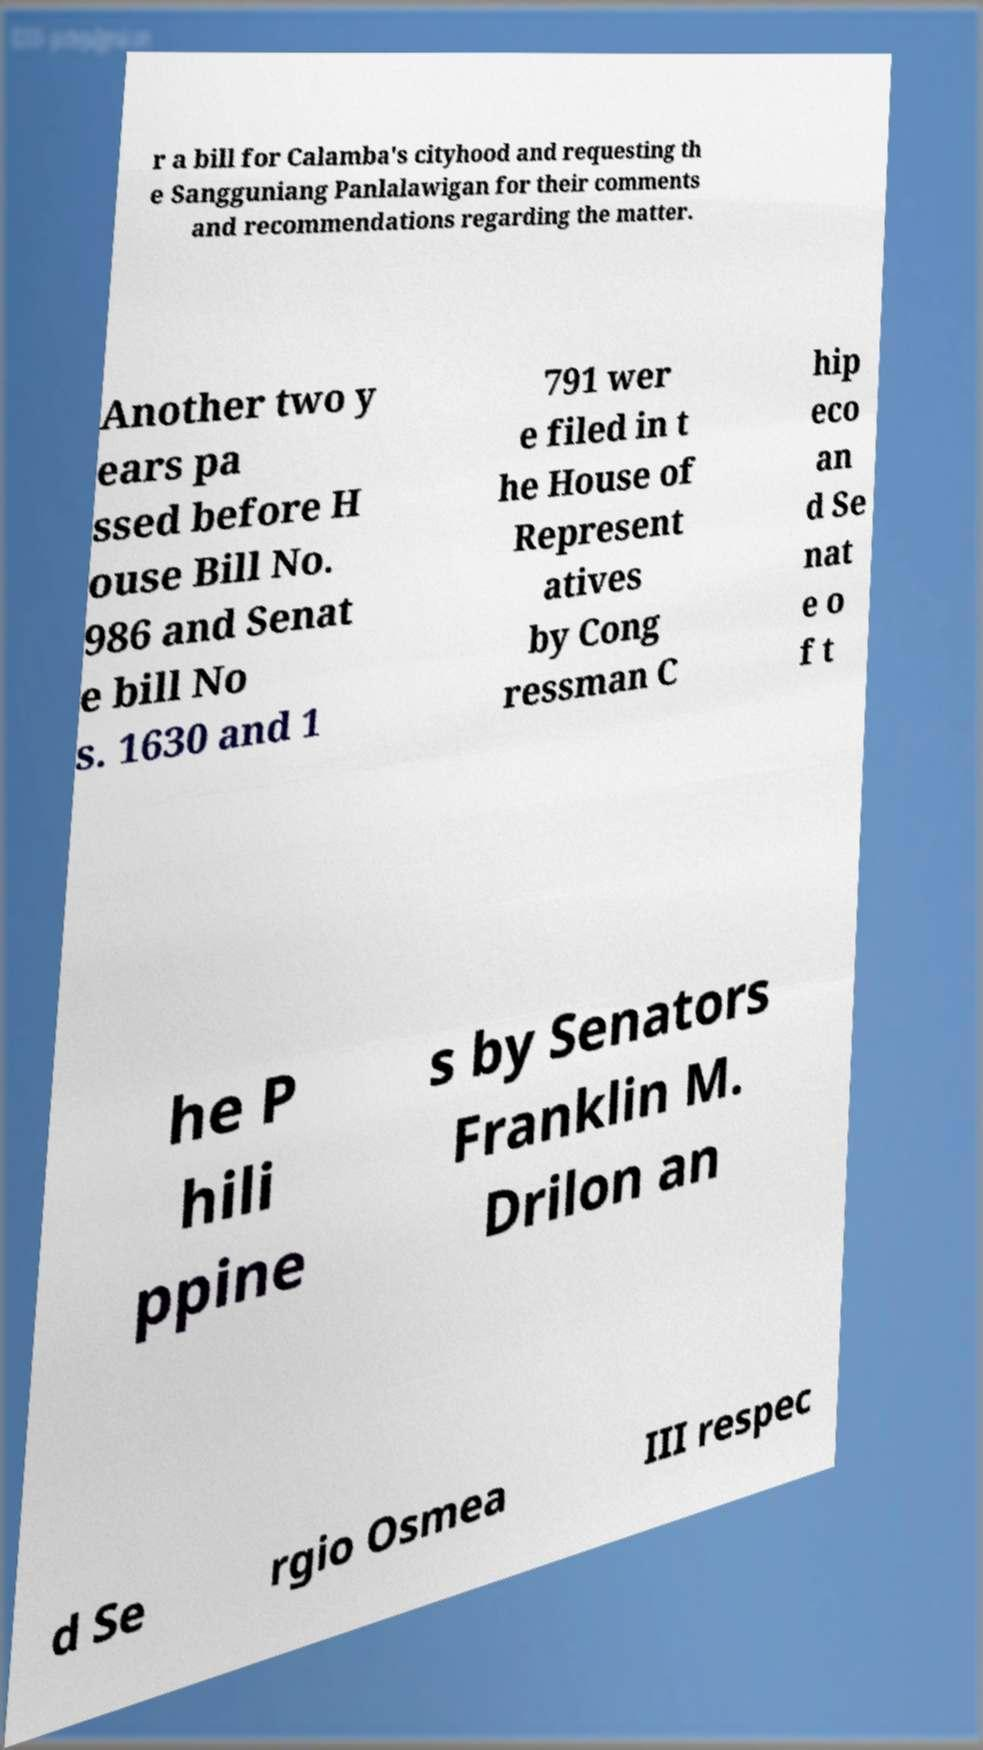Could you extract and type out the text from this image? r a bill for Calamba's cityhood and requesting th e Sangguniang Panlalawigan for their comments and recommendations regarding the matter. Another two y ears pa ssed before H ouse Bill No. 986 and Senat e bill No s. 1630 and 1 791 wer e filed in t he House of Represent atives by Cong ressman C hip eco an d Se nat e o f t he P hili ppine s by Senators Franklin M. Drilon an d Se rgio Osmea III respec 